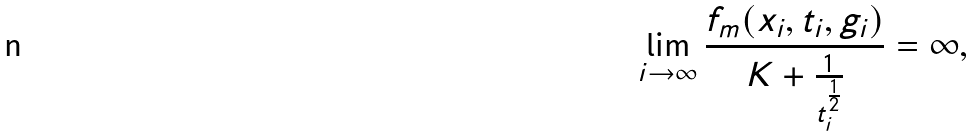Convert formula to latex. <formula><loc_0><loc_0><loc_500><loc_500>\lim _ { i \to \infty } \frac { f _ { m } ( x _ { i } , t _ { i } , g _ { i } ) } { K + \frac { 1 } { t _ { i } ^ { \frac { 1 } { 2 } } } } = \infty ,</formula> 